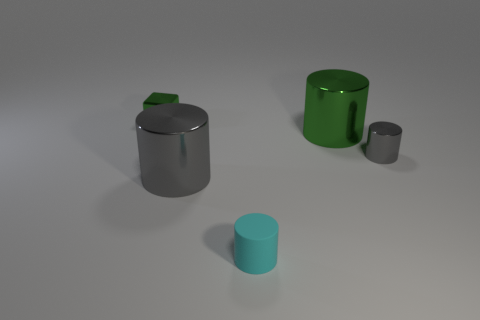What number of big metallic cylinders have the same color as the tiny metal cylinder? There is one large metallic cylinder that shares the same hue of gray as the small metal cylinder in the image. 